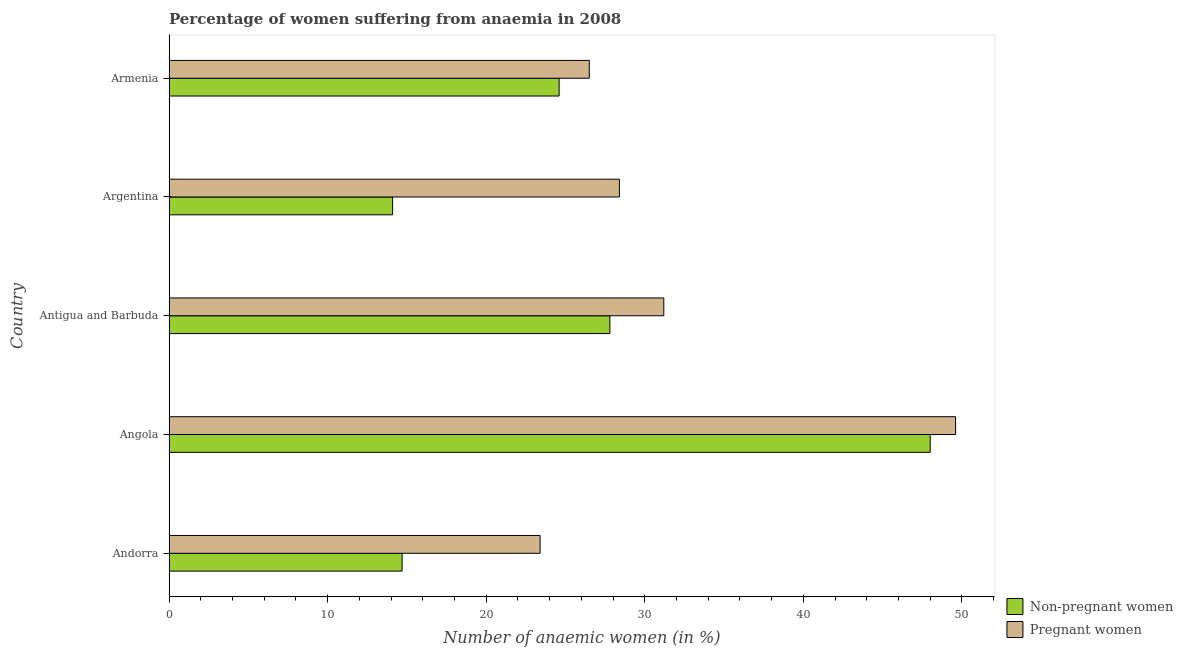How many different coloured bars are there?
Your answer should be compact. 2. How many groups of bars are there?
Your answer should be compact. 5. Are the number of bars on each tick of the Y-axis equal?
Provide a short and direct response. Yes. How many bars are there on the 3rd tick from the bottom?
Your response must be concise. 2. What is the label of the 4th group of bars from the top?
Your answer should be very brief. Angola. In how many cases, is the number of bars for a given country not equal to the number of legend labels?
Offer a terse response. 0. What is the percentage of pregnant anaemic women in Antigua and Barbuda?
Your answer should be very brief. 31.2. Across all countries, what is the minimum percentage of pregnant anaemic women?
Provide a short and direct response. 23.4. In which country was the percentage of pregnant anaemic women maximum?
Give a very brief answer. Angola. In which country was the percentage of pregnant anaemic women minimum?
Offer a very short reply. Andorra. What is the total percentage of non-pregnant anaemic women in the graph?
Give a very brief answer. 129.2. What is the difference between the percentage of non-pregnant anaemic women in Angola and that in Antigua and Barbuda?
Offer a very short reply. 20.2. What is the average percentage of non-pregnant anaemic women per country?
Provide a short and direct response. 25.84. What is the difference between the percentage of pregnant anaemic women and percentage of non-pregnant anaemic women in Armenia?
Make the answer very short. 1.9. In how many countries, is the percentage of non-pregnant anaemic women greater than 12 %?
Give a very brief answer. 5. What is the ratio of the percentage of pregnant anaemic women in Antigua and Barbuda to that in Armenia?
Your answer should be compact. 1.18. Is the difference between the percentage of pregnant anaemic women in Angola and Argentina greater than the difference between the percentage of non-pregnant anaemic women in Angola and Argentina?
Ensure brevity in your answer.  No. What is the difference between the highest and the second highest percentage of pregnant anaemic women?
Provide a succinct answer. 18.4. What is the difference between the highest and the lowest percentage of non-pregnant anaemic women?
Offer a terse response. 33.9. In how many countries, is the percentage of non-pregnant anaemic women greater than the average percentage of non-pregnant anaemic women taken over all countries?
Your answer should be very brief. 2. What does the 2nd bar from the top in Andorra represents?
Offer a very short reply. Non-pregnant women. What does the 2nd bar from the bottom in Antigua and Barbuda represents?
Give a very brief answer. Pregnant women. How many bars are there?
Keep it short and to the point. 10. Are all the bars in the graph horizontal?
Your answer should be very brief. Yes. Are the values on the major ticks of X-axis written in scientific E-notation?
Keep it short and to the point. No. Does the graph contain grids?
Your answer should be compact. No. Where does the legend appear in the graph?
Give a very brief answer. Bottom right. How are the legend labels stacked?
Offer a very short reply. Vertical. What is the title of the graph?
Offer a terse response. Percentage of women suffering from anaemia in 2008. What is the label or title of the X-axis?
Your answer should be compact. Number of anaemic women (in %). What is the label or title of the Y-axis?
Your answer should be very brief. Country. What is the Number of anaemic women (in %) of Pregnant women in Andorra?
Make the answer very short. 23.4. What is the Number of anaemic women (in %) in Non-pregnant women in Angola?
Keep it short and to the point. 48. What is the Number of anaemic women (in %) in Pregnant women in Angola?
Ensure brevity in your answer.  49.6. What is the Number of anaemic women (in %) of Non-pregnant women in Antigua and Barbuda?
Make the answer very short. 27.8. What is the Number of anaemic women (in %) of Pregnant women in Antigua and Barbuda?
Your answer should be compact. 31.2. What is the Number of anaemic women (in %) of Non-pregnant women in Argentina?
Give a very brief answer. 14.1. What is the Number of anaemic women (in %) of Pregnant women in Argentina?
Give a very brief answer. 28.4. What is the Number of anaemic women (in %) in Non-pregnant women in Armenia?
Offer a very short reply. 24.6. Across all countries, what is the maximum Number of anaemic women (in %) in Pregnant women?
Offer a terse response. 49.6. Across all countries, what is the minimum Number of anaemic women (in %) in Non-pregnant women?
Ensure brevity in your answer.  14.1. Across all countries, what is the minimum Number of anaemic women (in %) in Pregnant women?
Your answer should be compact. 23.4. What is the total Number of anaemic women (in %) of Non-pregnant women in the graph?
Your answer should be very brief. 129.2. What is the total Number of anaemic women (in %) in Pregnant women in the graph?
Offer a very short reply. 159.1. What is the difference between the Number of anaemic women (in %) of Non-pregnant women in Andorra and that in Angola?
Your response must be concise. -33.3. What is the difference between the Number of anaemic women (in %) of Pregnant women in Andorra and that in Angola?
Offer a very short reply. -26.2. What is the difference between the Number of anaemic women (in %) of Pregnant women in Andorra and that in Argentina?
Offer a terse response. -5. What is the difference between the Number of anaemic women (in %) in Non-pregnant women in Andorra and that in Armenia?
Make the answer very short. -9.9. What is the difference between the Number of anaemic women (in %) of Non-pregnant women in Angola and that in Antigua and Barbuda?
Keep it short and to the point. 20.2. What is the difference between the Number of anaemic women (in %) of Pregnant women in Angola and that in Antigua and Barbuda?
Your answer should be very brief. 18.4. What is the difference between the Number of anaemic women (in %) in Non-pregnant women in Angola and that in Argentina?
Offer a very short reply. 33.9. What is the difference between the Number of anaemic women (in %) of Pregnant women in Angola and that in Argentina?
Offer a terse response. 21.2. What is the difference between the Number of anaemic women (in %) of Non-pregnant women in Angola and that in Armenia?
Keep it short and to the point. 23.4. What is the difference between the Number of anaemic women (in %) of Pregnant women in Angola and that in Armenia?
Your answer should be compact. 23.1. What is the difference between the Number of anaemic women (in %) in Pregnant women in Antigua and Barbuda and that in Argentina?
Offer a very short reply. 2.8. What is the difference between the Number of anaemic women (in %) of Non-pregnant women in Antigua and Barbuda and that in Armenia?
Your answer should be very brief. 3.2. What is the difference between the Number of anaemic women (in %) of Non-pregnant women in Andorra and the Number of anaemic women (in %) of Pregnant women in Angola?
Offer a very short reply. -34.9. What is the difference between the Number of anaemic women (in %) in Non-pregnant women in Andorra and the Number of anaemic women (in %) in Pregnant women in Antigua and Barbuda?
Keep it short and to the point. -16.5. What is the difference between the Number of anaemic women (in %) of Non-pregnant women in Andorra and the Number of anaemic women (in %) of Pregnant women in Argentina?
Provide a succinct answer. -13.7. What is the difference between the Number of anaemic women (in %) in Non-pregnant women in Angola and the Number of anaemic women (in %) in Pregnant women in Antigua and Barbuda?
Provide a succinct answer. 16.8. What is the difference between the Number of anaemic women (in %) in Non-pregnant women in Angola and the Number of anaemic women (in %) in Pregnant women in Argentina?
Your response must be concise. 19.6. What is the difference between the Number of anaemic women (in %) of Non-pregnant women in Argentina and the Number of anaemic women (in %) of Pregnant women in Armenia?
Your answer should be compact. -12.4. What is the average Number of anaemic women (in %) in Non-pregnant women per country?
Your response must be concise. 25.84. What is the average Number of anaemic women (in %) in Pregnant women per country?
Your response must be concise. 31.82. What is the difference between the Number of anaemic women (in %) of Non-pregnant women and Number of anaemic women (in %) of Pregnant women in Andorra?
Ensure brevity in your answer.  -8.7. What is the difference between the Number of anaemic women (in %) in Non-pregnant women and Number of anaemic women (in %) in Pregnant women in Angola?
Provide a succinct answer. -1.6. What is the difference between the Number of anaemic women (in %) of Non-pregnant women and Number of anaemic women (in %) of Pregnant women in Argentina?
Provide a succinct answer. -14.3. What is the ratio of the Number of anaemic women (in %) in Non-pregnant women in Andorra to that in Angola?
Ensure brevity in your answer.  0.31. What is the ratio of the Number of anaemic women (in %) in Pregnant women in Andorra to that in Angola?
Offer a terse response. 0.47. What is the ratio of the Number of anaemic women (in %) in Non-pregnant women in Andorra to that in Antigua and Barbuda?
Give a very brief answer. 0.53. What is the ratio of the Number of anaemic women (in %) in Non-pregnant women in Andorra to that in Argentina?
Ensure brevity in your answer.  1.04. What is the ratio of the Number of anaemic women (in %) of Pregnant women in Andorra to that in Argentina?
Keep it short and to the point. 0.82. What is the ratio of the Number of anaemic women (in %) in Non-pregnant women in Andorra to that in Armenia?
Make the answer very short. 0.6. What is the ratio of the Number of anaemic women (in %) of Pregnant women in Andorra to that in Armenia?
Offer a terse response. 0.88. What is the ratio of the Number of anaemic women (in %) in Non-pregnant women in Angola to that in Antigua and Barbuda?
Give a very brief answer. 1.73. What is the ratio of the Number of anaemic women (in %) in Pregnant women in Angola to that in Antigua and Barbuda?
Offer a terse response. 1.59. What is the ratio of the Number of anaemic women (in %) in Non-pregnant women in Angola to that in Argentina?
Ensure brevity in your answer.  3.4. What is the ratio of the Number of anaemic women (in %) in Pregnant women in Angola to that in Argentina?
Make the answer very short. 1.75. What is the ratio of the Number of anaemic women (in %) in Non-pregnant women in Angola to that in Armenia?
Your response must be concise. 1.95. What is the ratio of the Number of anaemic women (in %) of Pregnant women in Angola to that in Armenia?
Give a very brief answer. 1.87. What is the ratio of the Number of anaemic women (in %) of Non-pregnant women in Antigua and Barbuda to that in Argentina?
Make the answer very short. 1.97. What is the ratio of the Number of anaemic women (in %) in Pregnant women in Antigua and Barbuda to that in Argentina?
Ensure brevity in your answer.  1.1. What is the ratio of the Number of anaemic women (in %) of Non-pregnant women in Antigua and Barbuda to that in Armenia?
Your answer should be very brief. 1.13. What is the ratio of the Number of anaemic women (in %) in Pregnant women in Antigua and Barbuda to that in Armenia?
Make the answer very short. 1.18. What is the ratio of the Number of anaemic women (in %) in Non-pregnant women in Argentina to that in Armenia?
Your response must be concise. 0.57. What is the ratio of the Number of anaemic women (in %) of Pregnant women in Argentina to that in Armenia?
Give a very brief answer. 1.07. What is the difference between the highest and the second highest Number of anaemic women (in %) of Non-pregnant women?
Give a very brief answer. 20.2. What is the difference between the highest and the lowest Number of anaemic women (in %) in Non-pregnant women?
Ensure brevity in your answer.  33.9. What is the difference between the highest and the lowest Number of anaemic women (in %) of Pregnant women?
Your answer should be compact. 26.2. 